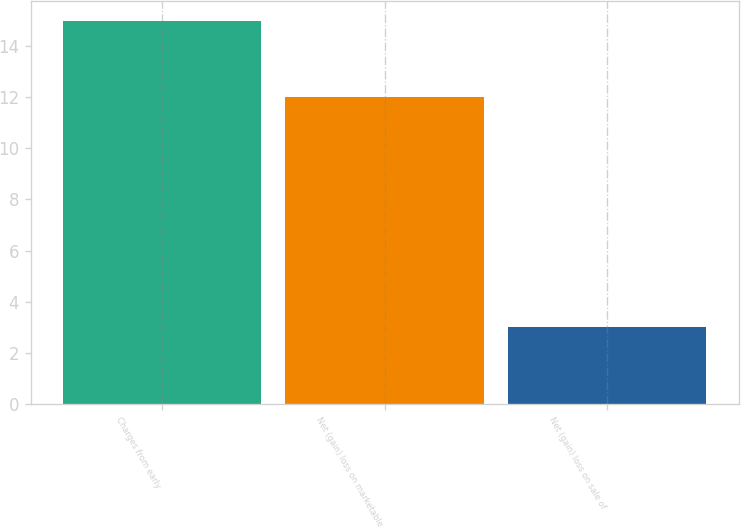<chart> <loc_0><loc_0><loc_500><loc_500><bar_chart><fcel>Charges from early<fcel>Net (gain) loss on marketable<fcel>Net (gain) loss on sale of<nl><fcel>15<fcel>12<fcel>3<nl></chart> 